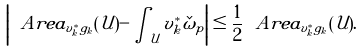<formula> <loc_0><loc_0><loc_500><loc_500>\left | \ A r e a _ { v _ { k } ^ { * } g _ { k } } ( \mathcal { U } ) - \int _ { \mathcal { U } } v _ { k } ^ { * } \check { \omega } _ { p } \right | \leq \frac { 1 } { 2 } \ A r e a _ { v _ { k } ^ { * } g _ { k } } ( \mathcal { U } ) .</formula> 